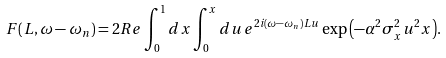<formula> <loc_0><loc_0><loc_500><loc_500>F ( L , \omega - \omega _ { n } ) = 2 R e \int _ { 0 } ^ { 1 } d x \int _ { 0 } ^ { x } d u \, e ^ { 2 i ( \omega - \omega _ { n } ) L u } \exp { \left ( - \alpha ^ { 2 } \sigma _ { x } ^ { 2 } u ^ { 2 } x \right ) } .</formula> 